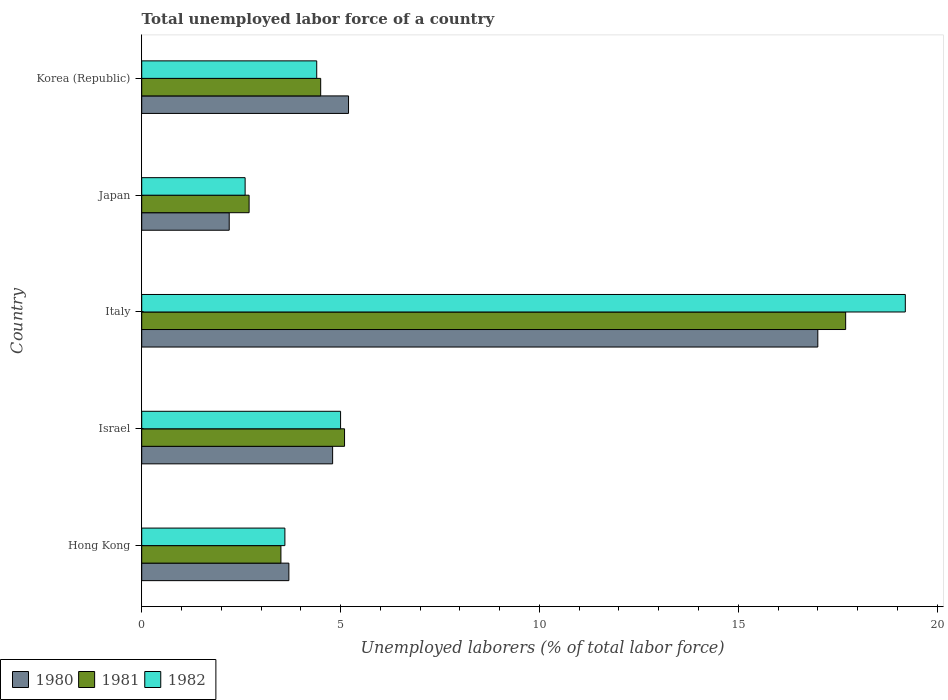How many groups of bars are there?
Your response must be concise. 5. Are the number of bars on each tick of the Y-axis equal?
Your response must be concise. Yes. How many bars are there on the 3rd tick from the top?
Offer a terse response. 3. What is the label of the 5th group of bars from the top?
Offer a terse response. Hong Kong. In how many cases, is the number of bars for a given country not equal to the number of legend labels?
Offer a terse response. 0. What is the total unemployed labor force in 1982 in Italy?
Give a very brief answer. 19.2. Across all countries, what is the minimum total unemployed labor force in 1980?
Make the answer very short. 2.2. In which country was the total unemployed labor force in 1982 maximum?
Provide a short and direct response. Italy. What is the total total unemployed labor force in 1981 in the graph?
Give a very brief answer. 33.5. What is the difference between the total unemployed labor force in 1981 in Israel and that in Korea (Republic)?
Give a very brief answer. 0.6. What is the difference between the total unemployed labor force in 1980 in Israel and the total unemployed labor force in 1982 in Japan?
Make the answer very short. 2.2. What is the average total unemployed labor force in 1981 per country?
Make the answer very short. 6.7. What is the ratio of the total unemployed labor force in 1981 in Hong Kong to that in Korea (Republic)?
Ensure brevity in your answer.  0.78. Is the total unemployed labor force in 1980 in Hong Kong less than that in Italy?
Your answer should be compact. Yes. What is the difference between the highest and the second highest total unemployed labor force in 1980?
Your answer should be very brief. 11.8. What is the difference between the highest and the lowest total unemployed labor force in 1980?
Provide a short and direct response. 14.8. Is the sum of the total unemployed labor force in 1982 in Hong Kong and Korea (Republic) greater than the maximum total unemployed labor force in 1981 across all countries?
Make the answer very short. No. Does the graph contain any zero values?
Provide a succinct answer. No. Does the graph contain grids?
Offer a terse response. No. Where does the legend appear in the graph?
Provide a short and direct response. Bottom left. How many legend labels are there?
Make the answer very short. 3. How are the legend labels stacked?
Keep it short and to the point. Horizontal. What is the title of the graph?
Your response must be concise. Total unemployed labor force of a country. Does "1963" appear as one of the legend labels in the graph?
Your answer should be compact. No. What is the label or title of the X-axis?
Provide a short and direct response. Unemployed laborers (% of total labor force). What is the Unemployed laborers (% of total labor force) of 1980 in Hong Kong?
Keep it short and to the point. 3.7. What is the Unemployed laborers (% of total labor force) in 1981 in Hong Kong?
Provide a short and direct response. 3.5. What is the Unemployed laborers (% of total labor force) in 1982 in Hong Kong?
Make the answer very short. 3.6. What is the Unemployed laborers (% of total labor force) in 1980 in Israel?
Provide a succinct answer. 4.8. What is the Unemployed laborers (% of total labor force) in 1981 in Israel?
Your answer should be very brief. 5.1. What is the Unemployed laborers (% of total labor force) of 1980 in Italy?
Make the answer very short. 17. What is the Unemployed laborers (% of total labor force) in 1981 in Italy?
Provide a short and direct response. 17.7. What is the Unemployed laborers (% of total labor force) in 1982 in Italy?
Offer a very short reply. 19.2. What is the Unemployed laborers (% of total labor force) in 1980 in Japan?
Give a very brief answer. 2.2. What is the Unemployed laborers (% of total labor force) of 1981 in Japan?
Your answer should be very brief. 2.7. What is the Unemployed laborers (% of total labor force) of 1982 in Japan?
Give a very brief answer. 2.6. What is the Unemployed laborers (% of total labor force) in 1980 in Korea (Republic)?
Offer a very short reply. 5.2. What is the Unemployed laborers (% of total labor force) in 1981 in Korea (Republic)?
Offer a terse response. 4.5. What is the Unemployed laborers (% of total labor force) in 1982 in Korea (Republic)?
Your answer should be compact. 4.4. Across all countries, what is the maximum Unemployed laborers (% of total labor force) in 1981?
Make the answer very short. 17.7. Across all countries, what is the maximum Unemployed laborers (% of total labor force) of 1982?
Make the answer very short. 19.2. Across all countries, what is the minimum Unemployed laborers (% of total labor force) of 1980?
Offer a terse response. 2.2. Across all countries, what is the minimum Unemployed laborers (% of total labor force) in 1981?
Give a very brief answer. 2.7. Across all countries, what is the minimum Unemployed laborers (% of total labor force) in 1982?
Keep it short and to the point. 2.6. What is the total Unemployed laborers (% of total labor force) of 1980 in the graph?
Your answer should be very brief. 32.9. What is the total Unemployed laborers (% of total labor force) of 1981 in the graph?
Ensure brevity in your answer.  33.5. What is the total Unemployed laborers (% of total labor force) in 1982 in the graph?
Provide a succinct answer. 34.8. What is the difference between the Unemployed laborers (% of total labor force) of 1982 in Hong Kong and that in Italy?
Ensure brevity in your answer.  -15.6. What is the difference between the Unemployed laborers (% of total labor force) in 1980 in Hong Kong and that in Japan?
Offer a terse response. 1.5. What is the difference between the Unemployed laborers (% of total labor force) in 1980 in Israel and that in Italy?
Your answer should be very brief. -12.2. What is the difference between the Unemployed laborers (% of total labor force) in 1980 in Israel and that in Japan?
Provide a succinct answer. 2.6. What is the difference between the Unemployed laborers (% of total labor force) of 1982 in Israel and that in Japan?
Ensure brevity in your answer.  2.4. What is the difference between the Unemployed laborers (% of total labor force) in 1980 in Israel and that in Korea (Republic)?
Provide a succinct answer. -0.4. What is the difference between the Unemployed laborers (% of total labor force) of 1981 in Israel and that in Korea (Republic)?
Offer a very short reply. 0.6. What is the difference between the Unemployed laborers (% of total labor force) in 1982 in Israel and that in Korea (Republic)?
Make the answer very short. 0.6. What is the difference between the Unemployed laborers (% of total labor force) in 1982 in Italy and that in Japan?
Keep it short and to the point. 16.6. What is the difference between the Unemployed laborers (% of total labor force) of 1982 in Italy and that in Korea (Republic)?
Offer a very short reply. 14.8. What is the difference between the Unemployed laborers (% of total labor force) in 1980 in Japan and that in Korea (Republic)?
Offer a terse response. -3. What is the difference between the Unemployed laborers (% of total labor force) of 1981 in Japan and that in Korea (Republic)?
Ensure brevity in your answer.  -1.8. What is the difference between the Unemployed laborers (% of total labor force) in 1981 in Hong Kong and the Unemployed laborers (% of total labor force) in 1982 in Israel?
Make the answer very short. -1.5. What is the difference between the Unemployed laborers (% of total labor force) in 1980 in Hong Kong and the Unemployed laborers (% of total labor force) in 1982 in Italy?
Your answer should be compact. -15.5. What is the difference between the Unemployed laborers (% of total labor force) of 1981 in Hong Kong and the Unemployed laborers (% of total labor force) of 1982 in Italy?
Make the answer very short. -15.7. What is the difference between the Unemployed laborers (% of total labor force) of 1980 in Hong Kong and the Unemployed laborers (% of total labor force) of 1981 in Korea (Republic)?
Your response must be concise. -0.8. What is the difference between the Unemployed laborers (% of total labor force) of 1981 in Hong Kong and the Unemployed laborers (% of total labor force) of 1982 in Korea (Republic)?
Your answer should be very brief. -0.9. What is the difference between the Unemployed laborers (% of total labor force) of 1980 in Israel and the Unemployed laborers (% of total labor force) of 1981 in Italy?
Offer a terse response. -12.9. What is the difference between the Unemployed laborers (% of total labor force) of 1980 in Israel and the Unemployed laborers (% of total labor force) of 1982 in Italy?
Make the answer very short. -14.4. What is the difference between the Unemployed laborers (% of total labor force) of 1981 in Israel and the Unemployed laborers (% of total labor force) of 1982 in Italy?
Provide a succinct answer. -14.1. What is the difference between the Unemployed laborers (% of total labor force) in 1980 in Israel and the Unemployed laborers (% of total labor force) in 1981 in Japan?
Your response must be concise. 2.1. What is the difference between the Unemployed laborers (% of total labor force) of 1980 in Israel and the Unemployed laborers (% of total labor force) of 1981 in Korea (Republic)?
Offer a terse response. 0.3. What is the difference between the Unemployed laborers (% of total labor force) in 1980 in Israel and the Unemployed laborers (% of total labor force) in 1982 in Korea (Republic)?
Offer a terse response. 0.4. What is the difference between the Unemployed laborers (% of total labor force) of 1981 in Israel and the Unemployed laborers (% of total labor force) of 1982 in Korea (Republic)?
Your response must be concise. 0.7. What is the difference between the Unemployed laborers (% of total labor force) in 1981 in Italy and the Unemployed laborers (% of total labor force) in 1982 in Japan?
Provide a succinct answer. 15.1. What is the difference between the Unemployed laborers (% of total labor force) in 1980 in Italy and the Unemployed laborers (% of total labor force) in 1981 in Korea (Republic)?
Offer a terse response. 12.5. What is the difference between the Unemployed laborers (% of total labor force) in 1980 in Italy and the Unemployed laborers (% of total labor force) in 1982 in Korea (Republic)?
Keep it short and to the point. 12.6. What is the difference between the Unemployed laborers (% of total labor force) in 1980 in Japan and the Unemployed laborers (% of total labor force) in 1981 in Korea (Republic)?
Ensure brevity in your answer.  -2.3. What is the difference between the Unemployed laborers (% of total labor force) of 1980 in Japan and the Unemployed laborers (% of total labor force) of 1982 in Korea (Republic)?
Provide a succinct answer. -2.2. What is the average Unemployed laborers (% of total labor force) in 1980 per country?
Offer a terse response. 6.58. What is the average Unemployed laborers (% of total labor force) of 1981 per country?
Offer a very short reply. 6.7. What is the average Unemployed laborers (% of total labor force) of 1982 per country?
Offer a terse response. 6.96. What is the difference between the Unemployed laborers (% of total labor force) of 1980 and Unemployed laborers (% of total labor force) of 1981 in Hong Kong?
Provide a short and direct response. 0.2. What is the difference between the Unemployed laborers (% of total labor force) of 1981 and Unemployed laborers (% of total labor force) of 1982 in Hong Kong?
Your answer should be very brief. -0.1. What is the difference between the Unemployed laborers (% of total labor force) in 1980 and Unemployed laborers (% of total labor force) in 1981 in Israel?
Your response must be concise. -0.3. What is the difference between the Unemployed laborers (% of total labor force) of 1980 and Unemployed laborers (% of total labor force) of 1982 in Israel?
Ensure brevity in your answer.  -0.2. What is the difference between the Unemployed laborers (% of total labor force) in 1980 and Unemployed laborers (% of total labor force) in 1981 in Italy?
Keep it short and to the point. -0.7. What is the difference between the Unemployed laborers (% of total labor force) of 1980 and Unemployed laborers (% of total labor force) of 1981 in Korea (Republic)?
Your response must be concise. 0.7. What is the difference between the Unemployed laborers (% of total labor force) in 1981 and Unemployed laborers (% of total labor force) in 1982 in Korea (Republic)?
Your response must be concise. 0.1. What is the ratio of the Unemployed laborers (% of total labor force) in 1980 in Hong Kong to that in Israel?
Provide a succinct answer. 0.77. What is the ratio of the Unemployed laborers (% of total labor force) of 1981 in Hong Kong to that in Israel?
Your answer should be very brief. 0.69. What is the ratio of the Unemployed laborers (% of total labor force) of 1982 in Hong Kong to that in Israel?
Offer a terse response. 0.72. What is the ratio of the Unemployed laborers (% of total labor force) of 1980 in Hong Kong to that in Italy?
Your response must be concise. 0.22. What is the ratio of the Unemployed laborers (% of total labor force) in 1981 in Hong Kong to that in Italy?
Your response must be concise. 0.2. What is the ratio of the Unemployed laborers (% of total labor force) of 1982 in Hong Kong to that in Italy?
Ensure brevity in your answer.  0.19. What is the ratio of the Unemployed laborers (% of total labor force) of 1980 in Hong Kong to that in Japan?
Keep it short and to the point. 1.68. What is the ratio of the Unemployed laborers (% of total labor force) of 1981 in Hong Kong to that in Japan?
Your answer should be very brief. 1.3. What is the ratio of the Unemployed laborers (% of total labor force) of 1982 in Hong Kong to that in Japan?
Keep it short and to the point. 1.38. What is the ratio of the Unemployed laborers (% of total labor force) of 1980 in Hong Kong to that in Korea (Republic)?
Your answer should be compact. 0.71. What is the ratio of the Unemployed laborers (% of total labor force) in 1982 in Hong Kong to that in Korea (Republic)?
Provide a short and direct response. 0.82. What is the ratio of the Unemployed laborers (% of total labor force) of 1980 in Israel to that in Italy?
Make the answer very short. 0.28. What is the ratio of the Unemployed laborers (% of total labor force) in 1981 in Israel to that in Italy?
Your response must be concise. 0.29. What is the ratio of the Unemployed laborers (% of total labor force) of 1982 in Israel to that in Italy?
Your response must be concise. 0.26. What is the ratio of the Unemployed laborers (% of total labor force) of 1980 in Israel to that in Japan?
Ensure brevity in your answer.  2.18. What is the ratio of the Unemployed laborers (% of total labor force) in 1981 in Israel to that in Japan?
Give a very brief answer. 1.89. What is the ratio of the Unemployed laborers (% of total labor force) of 1982 in Israel to that in Japan?
Your answer should be compact. 1.92. What is the ratio of the Unemployed laborers (% of total labor force) of 1981 in Israel to that in Korea (Republic)?
Provide a short and direct response. 1.13. What is the ratio of the Unemployed laborers (% of total labor force) in 1982 in Israel to that in Korea (Republic)?
Your response must be concise. 1.14. What is the ratio of the Unemployed laborers (% of total labor force) in 1980 in Italy to that in Japan?
Provide a succinct answer. 7.73. What is the ratio of the Unemployed laborers (% of total labor force) in 1981 in Italy to that in Japan?
Keep it short and to the point. 6.56. What is the ratio of the Unemployed laborers (% of total labor force) in 1982 in Italy to that in Japan?
Keep it short and to the point. 7.38. What is the ratio of the Unemployed laborers (% of total labor force) in 1980 in Italy to that in Korea (Republic)?
Provide a short and direct response. 3.27. What is the ratio of the Unemployed laborers (% of total labor force) in 1981 in Italy to that in Korea (Republic)?
Offer a very short reply. 3.93. What is the ratio of the Unemployed laborers (% of total labor force) of 1982 in Italy to that in Korea (Republic)?
Your answer should be very brief. 4.36. What is the ratio of the Unemployed laborers (% of total labor force) in 1980 in Japan to that in Korea (Republic)?
Keep it short and to the point. 0.42. What is the ratio of the Unemployed laborers (% of total labor force) in 1982 in Japan to that in Korea (Republic)?
Give a very brief answer. 0.59. What is the difference between the highest and the second highest Unemployed laborers (% of total labor force) of 1980?
Provide a short and direct response. 11.8. What is the difference between the highest and the second highest Unemployed laborers (% of total labor force) of 1981?
Provide a succinct answer. 12.6. What is the difference between the highest and the second highest Unemployed laborers (% of total labor force) of 1982?
Offer a terse response. 14.2. What is the difference between the highest and the lowest Unemployed laborers (% of total labor force) of 1982?
Provide a succinct answer. 16.6. 